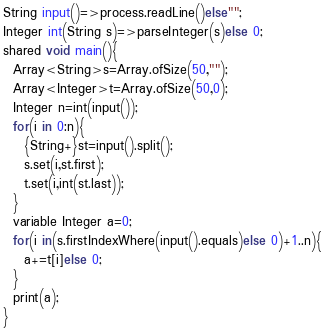Convert code to text. <code><loc_0><loc_0><loc_500><loc_500><_Ceylon_>String input()=>process.readLine()else""; 
Integer int(String s)=>parseInteger(s)else 0;
shared void main(){
  Array<String>s=Array.ofSize(50,"");
  Array<Integer>t=Array.ofSize(50,0);
  Integer n=int(input());
  for(i in 0:n){
    {String+}st=input().split();
    s.set(i,st.first);
    t.set(i,int(st.last));
  }
  variable Integer a=0;
  for(i in(s.firstIndexWhere(input().equals)else 0)+1..n){
    a+=t[i]else 0;
  }
  print(a);
}
</code> 